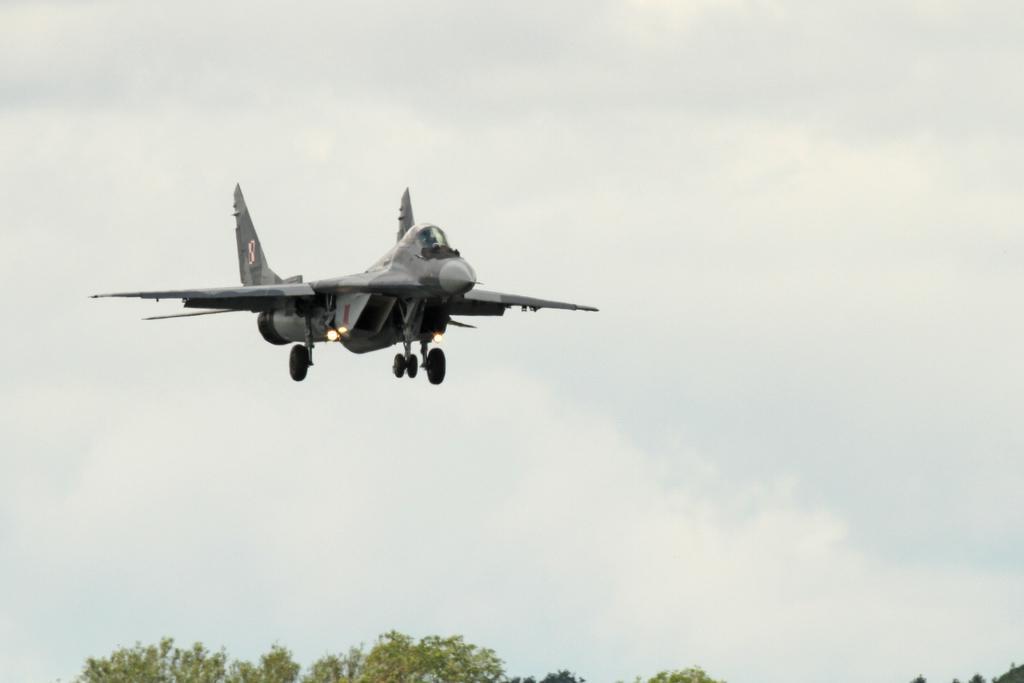Can you describe this image briefly? In this image I can see an aircraft, background I can see few trees in green color and the sky is in white color. 